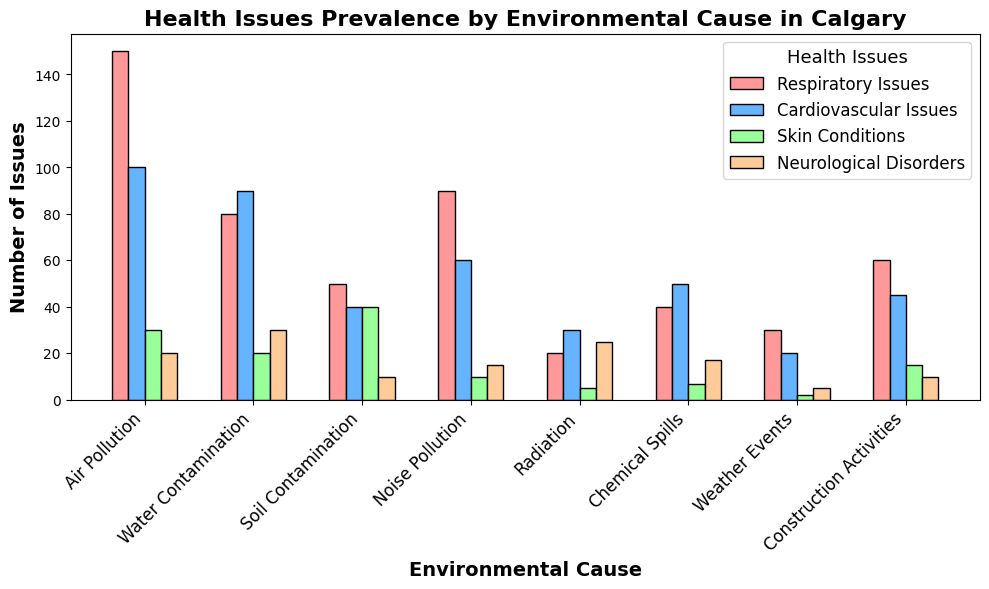What are the top three environmental causes of respiratory issues? First, identify the bar heights for respiratory issues across all environmental causes. Air Pollution has 150, Noise Pollution has 90, and Water Contamination has 80. Thus, the top three are Air Pollution, Noise Pollution, and Water Contamination.
Answer: Air Pollution, Noise Pollution, and Water Contamination Which environmental cause has the highest number of cardiovascular issues? Look at the bar heights for cardiovascular issues and see which bar is the tallest. Water Contamination has 90, which is higher than the other bars for this category.
Answer: Water Contamination How many more respiratory issues are there due to Air Pollution compared to Chemical Spills? Identify the height of the bars for respiratory issues caused by Air Pollution (150) and Chemical Spills (40). Subtract the smaller from the larger: 150 - 40 = 110.
Answer: 110 more What is the total number of skin conditions caused by all environmental factors combined? Sum all the bar heights for skin conditions reported for each environmental cause: 30 (Air Pollution) + 20 (Water Contamination) + 40 (Soil Contamination) + 10 (Noise Pollution) + 5 (Radiation) + 7 (Chemical Spills) + 2 (Weather Events) + 15 (Construction Activities) = 129.
Answer: 129 Do neurological disorders caused by Water Contamination outnumber those caused by Radiation? Compare the bar heights for neurological disorders: Water Contamination has 30, and Radiation has 25. Since 30 > 25, Water Contamination has more.
Answer: Yes Which environmental cause has the fewest health issues in total? Calculate the sum of all health issues categories for each cause. For example:
  - Air Pollution: 150 + 100 + 30 + 20 = 300
  - Water Contamination: 80 + 90 + 20 + 30 = 220
  - Soil Contamination: 50 + 40 + 40 + 10 = 140
  - Noise Pollution: 90 + 60 + 10 + 15 = 175
  - Radiation: 20 + 30 + 5 + 25 = 80
  - Chemical Spills: 40 + 50 + 7 + 17 = 114
  - Weather Events: 30 + 20 + 2 + 5 = 57
  - Construction Activities: 60 + 45 + 15 + 10 = 130
  From these sums, Weather Events (57) has the fewest.
Answer: Weather Events Which environmental cause has approximately equal numbers of respiratory and cardiovascular issues? Compare the bars for respiratory and cardiovascular issues for each environmental cause. Only Water Contamination (80 respiratory, 90 cardiovascular) has nearly the same numbers.
Answer: Water Contamination How does the number of skin conditions from Soil Contamination compare to the total number of issues from Radiation? The bar for skin conditions from Soil Contamination is 40. Sum all the issues from Radiation: 20 (Respiratory) + 30 (Cardiovascular) + 5 (Skin) + 25 (Neurological) = 80. Thus, 40 is compared to 80.
Answer: Less than half 